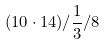<formula> <loc_0><loc_0><loc_500><loc_500>( 1 0 \cdot 1 4 ) / \frac { 1 } { 3 } / 8</formula> 